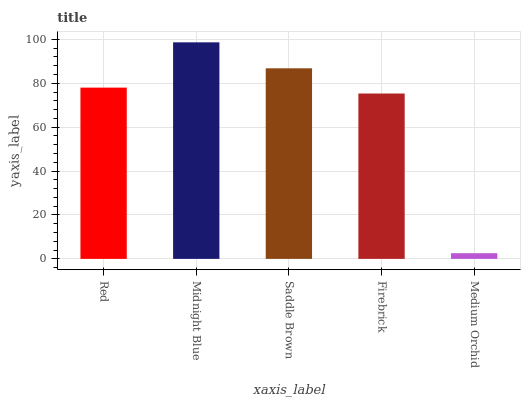Is Medium Orchid the minimum?
Answer yes or no. Yes. Is Midnight Blue the maximum?
Answer yes or no. Yes. Is Saddle Brown the minimum?
Answer yes or no. No. Is Saddle Brown the maximum?
Answer yes or no. No. Is Midnight Blue greater than Saddle Brown?
Answer yes or no. Yes. Is Saddle Brown less than Midnight Blue?
Answer yes or no. Yes. Is Saddle Brown greater than Midnight Blue?
Answer yes or no. No. Is Midnight Blue less than Saddle Brown?
Answer yes or no. No. Is Red the high median?
Answer yes or no. Yes. Is Red the low median?
Answer yes or no. Yes. Is Firebrick the high median?
Answer yes or no. No. Is Medium Orchid the low median?
Answer yes or no. No. 